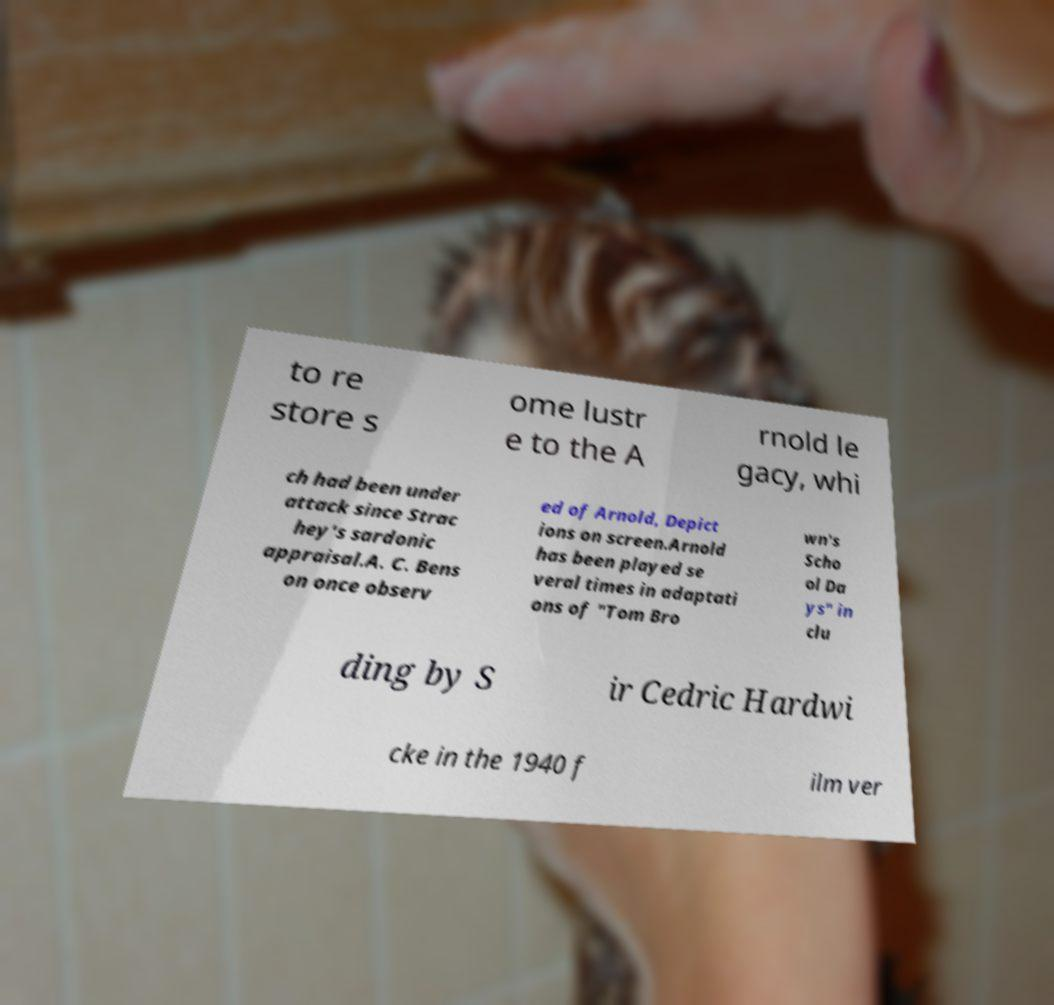There's text embedded in this image that I need extracted. Can you transcribe it verbatim? to re store s ome lustr e to the A rnold le gacy, whi ch had been under attack since Strac hey's sardonic appraisal.A. C. Bens on once observ ed of Arnold, Depict ions on screen.Arnold has been played se veral times in adaptati ons of "Tom Bro wn's Scho ol Da ys" in clu ding by S ir Cedric Hardwi cke in the 1940 f ilm ver 